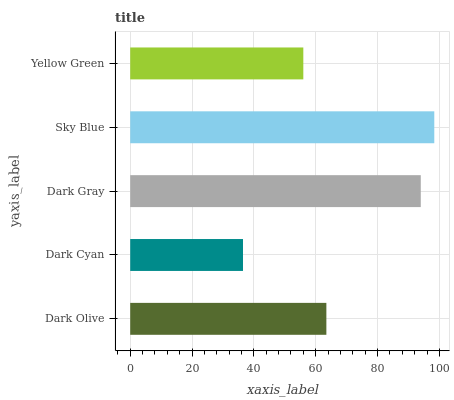Is Dark Cyan the minimum?
Answer yes or no. Yes. Is Sky Blue the maximum?
Answer yes or no. Yes. Is Dark Gray the minimum?
Answer yes or no. No. Is Dark Gray the maximum?
Answer yes or no. No. Is Dark Gray greater than Dark Cyan?
Answer yes or no. Yes. Is Dark Cyan less than Dark Gray?
Answer yes or no. Yes. Is Dark Cyan greater than Dark Gray?
Answer yes or no. No. Is Dark Gray less than Dark Cyan?
Answer yes or no. No. Is Dark Olive the high median?
Answer yes or no. Yes. Is Dark Olive the low median?
Answer yes or no. Yes. Is Dark Cyan the high median?
Answer yes or no. No. Is Dark Gray the low median?
Answer yes or no. No. 